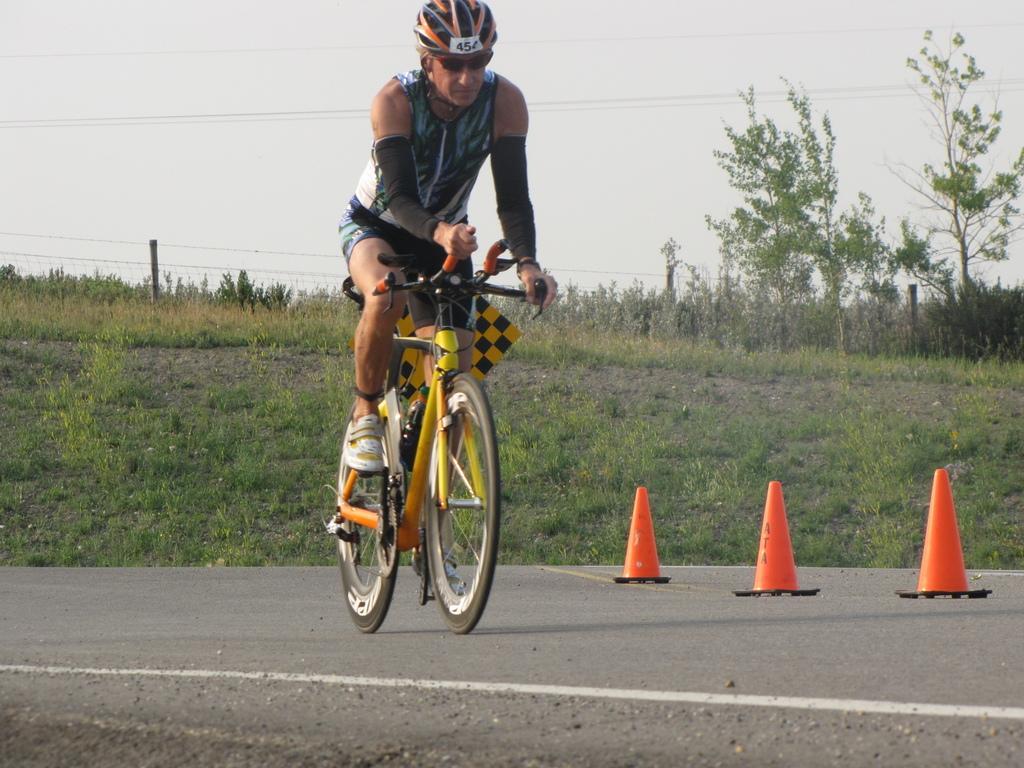Can you describe this image briefly? In this picture we can see a man is riding bicycle on the road, and he wore a helmet, beside to him we can find few road divide objects, in the background we can see trees. 